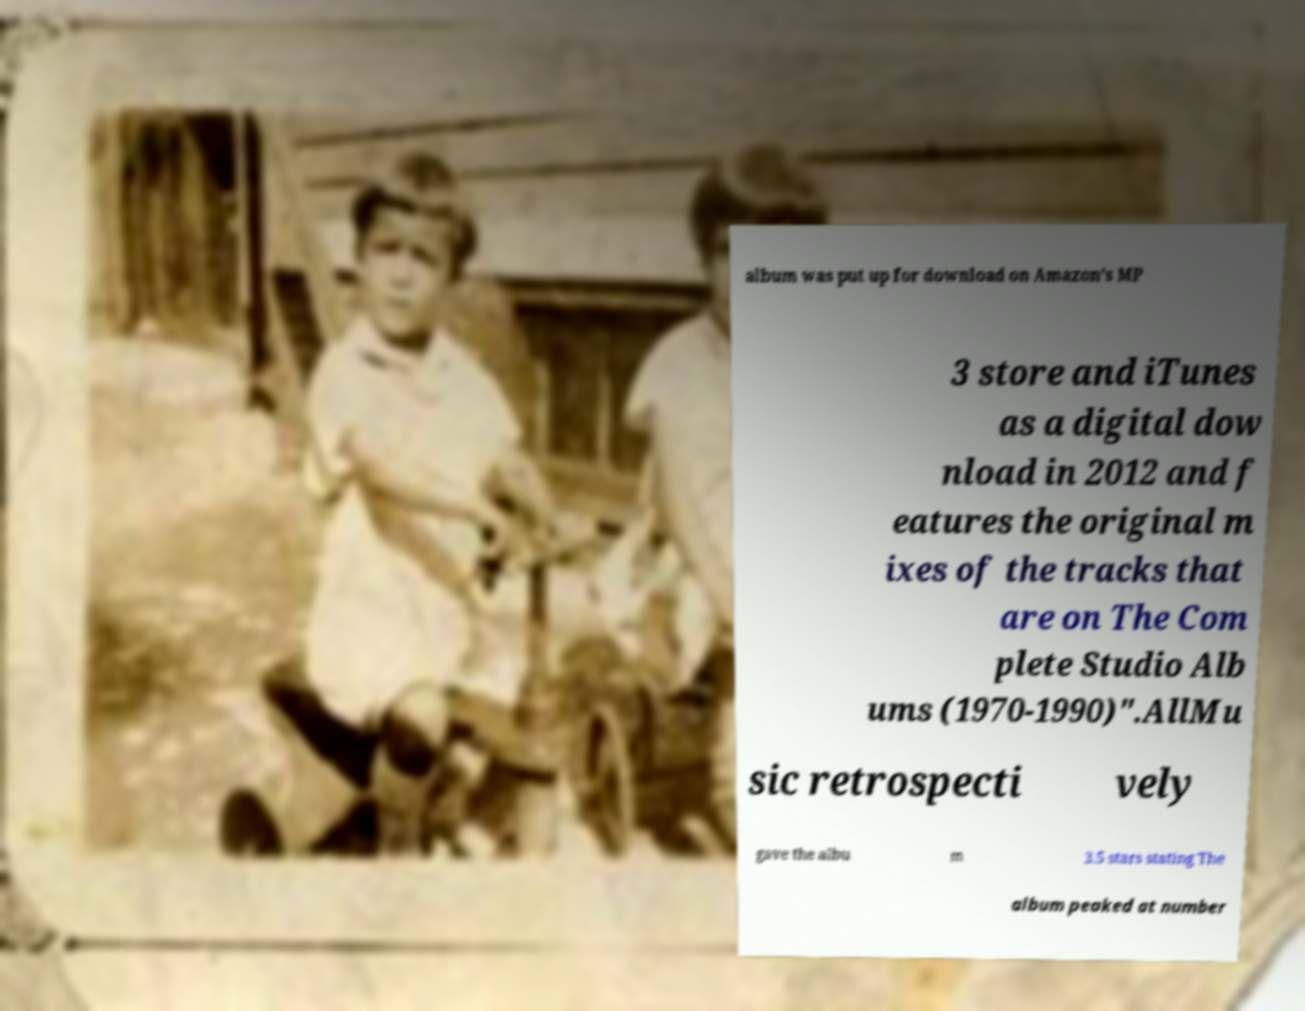For documentation purposes, I need the text within this image transcribed. Could you provide that? album was put up for download on Amazon's MP 3 store and iTunes as a digital dow nload in 2012 and f eatures the original m ixes of the tracks that are on The Com plete Studio Alb ums (1970-1990)".AllMu sic retrospecti vely gave the albu m 3.5 stars stating The album peaked at number 